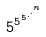<formula> <loc_0><loc_0><loc_500><loc_500>5 ^ { 5 ^ { 5 ^ { . ^ { . ^ { n } } } } }</formula> 